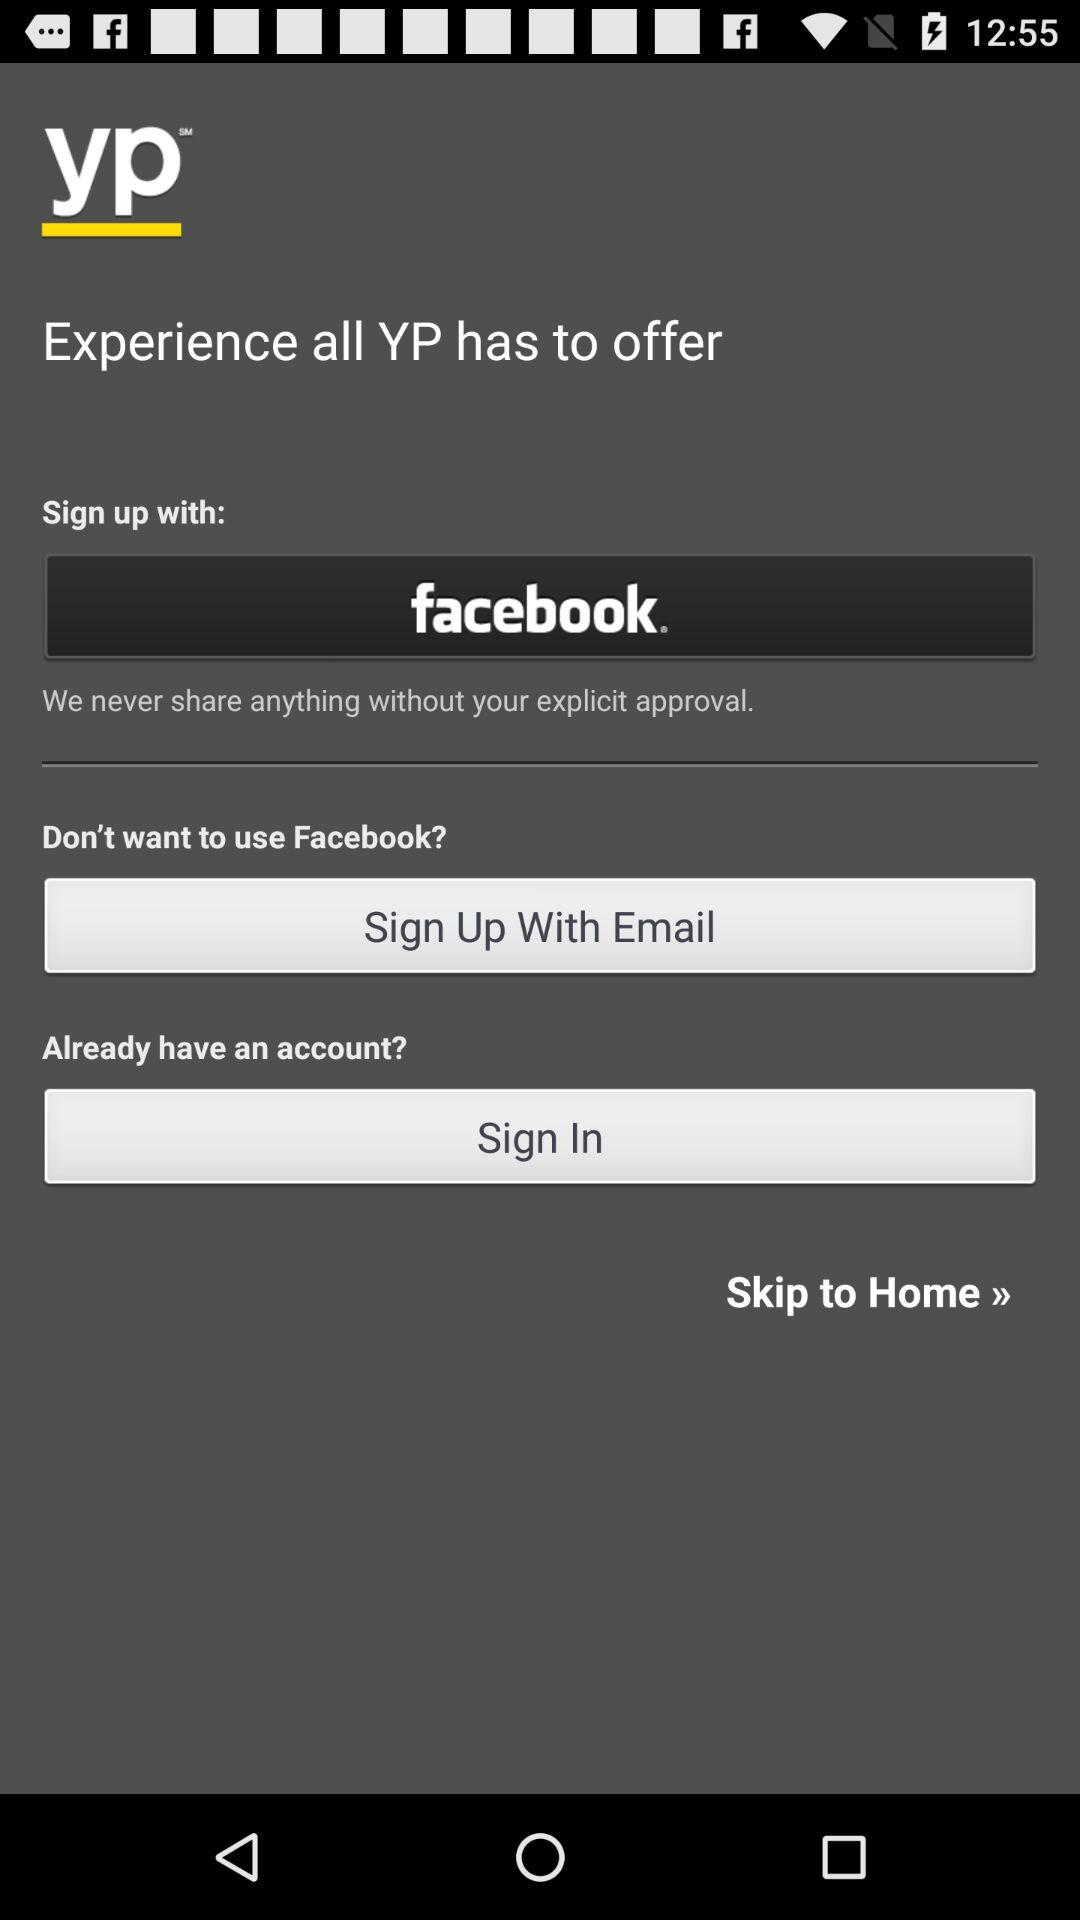How many sign up options are available?
Answer the question using a single word or phrase. 3 